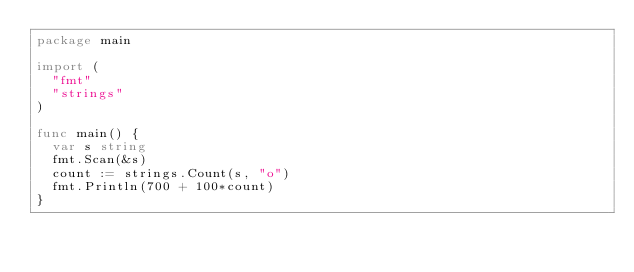Convert code to text. <code><loc_0><loc_0><loc_500><loc_500><_Go_>package main

import (
	"fmt"
	"strings"
)

func main() {
	var s string
	fmt.Scan(&s)
	count := strings.Count(s, "o")
	fmt.Println(700 + 100*count)
}
</code> 